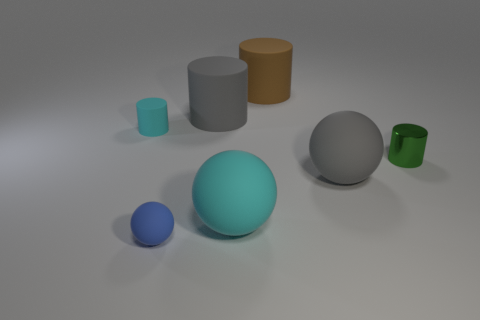What is the size of the rubber ball that is the same color as the small matte cylinder?
Your answer should be very brief. Large. There is another rubber object that is the same size as the blue thing; what color is it?
Give a very brief answer. Cyan. What material is the tiny cylinder on the right side of the gray object that is behind the big gray thing in front of the green metallic cylinder?
Make the answer very short. Metal. Do the small matte cylinder and the large ball on the left side of the brown matte object have the same color?
Keep it short and to the point. Yes. How many things are tiny objects left of the blue matte ball or cyan things that are behind the tiny green cylinder?
Your response must be concise. 1. What is the shape of the object on the left side of the tiny matte object in front of the big cyan matte object?
Your answer should be very brief. Cylinder. Is there a cyan object made of the same material as the big gray ball?
Your response must be concise. Yes. There is another large thing that is the same shape as the brown object; what is its color?
Your answer should be compact. Gray. Are there fewer tiny spheres to the right of the brown cylinder than large gray matte things that are to the right of the big gray cylinder?
Provide a short and direct response. Yes. How many other objects are there of the same shape as the brown matte object?
Provide a succinct answer. 3. 